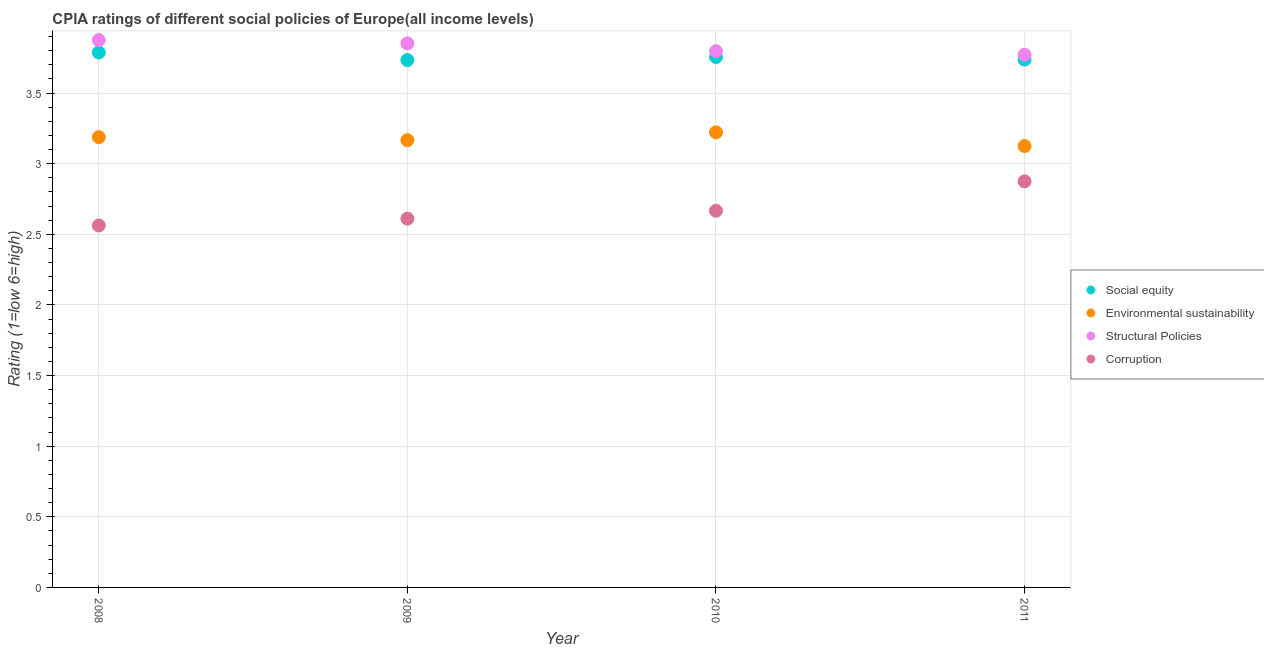How many different coloured dotlines are there?
Keep it short and to the point. 4. Is the number of dotlines equal to the number of legend labels?
Keep it short and to the point. Yes. What is the cpia rating of structural policies in 2010?
Provide a short and direct response. 3.8. Across all years, what is the maximum cpia rating of structural policies?
Offer a terse response. 3.88. Across all years, what is the minimum cpia rating of social equity?
Offer a very short reply. 3.73. What is the total cpia rating of structural policies in the graph?
Provide a short and direct response. 15.29. What is the difference between the cpia rating of structural policies in 2010 and that in 2011?
Your answer should be compact. 0.03. What is the difference between the cpia rating of corruption in 2011 and the cpia rating of social equity in 2008?
Provide a short and direct response. -0.91. What is the average cpia rating of social equity per year?
Provide a short and direct response. 3.75. In the year 2009, what is the difference between the cpia rating of social equity and cpia rating of environmental sustainability?
Your response must be concise. 0.57. In how many years, is the cpia rating of corruption greater than 2.4?
Offer a terse response. 4. What is the ratio of the cpia rating of environmental sustainability in 2009 to that in 2010?
Provide a short and direct response. 0.98. Is the cpia rating of environmental sustainability in 2008 less than that in 2010?
Your response must be concise. Yes. What is the difference between the highest and the second highest cpia rating of environmental sustainability?
Ensure brevity in your answer.  0.03. What is the difference between the highest and the lowest cpia rating of social equity?
Offer a terse response. 0.05. Is it the case that in every year, the sum of the cpia rating of environmental sustainability and cpia rating of structural policies is greater than the sum of cpia rating of social equity and cpia rating of corruption?
Your response must be concise. No. Is the cpia rating of environmental sustainability strictly greater than the cpia rating of corruption over the years?
Your answer should be compact. Yes. How many years are there in the graph?
Give a very brief answer. 4. What is the difference between two consecutive major ticks on the Y-axis?
Your answer should be very brief. 0.5. Are the values on the major ticks of Y-axis written in scientific E-notation?
Provide a short and direct response. No. Does the graph contain any zero values?
Ensure brevity in your answer.  No. How many legend labels are there?
Your answer should be very brief. 4. How are the legend labels stacked?
Give a very brief answer. Vertical. What is the title of the graph?
Your answer should be very brief. CPIA ratings of different social policies of Europe(all income levels). What is the label or title of the X-axis?
Make the answer very short. Year. What is the Rating (1=low 6=high) in Social equity in 2008?
Offer a terse response. 3.79. What is the Rating (1=low 6=high) in Environmental sustainability in 2008?
Your answer should be compact. 3.19. What is the Rating (1=low 6=high) of Structural Policies in 2008?
Keep it short and to the point. 3.88. What is the Rating (1=low 6=high) of Corruption in 2008?
Offer a very short reply. 2.56. What is the Rating (1=low 6=high) in Social equity in 2009?
Ensure brevity in your answer.  3.73. What is the Rating (1=low 6=high) in Environmental sustainability in 2009?
Your answer should be compact. 3.17. What is the Rating (1=low 6=high) of Structural Policies in 2009?
Offer a terse response. 3.85. What is the Rating (1=low 6=high) of Corruption in 2009?
Your response must be concise. 2.61. What is the Rating (1=low 6=high) in Social equity in 2010?
Keep it short and to the point. 3.76. What is the Rating (1=low 6=high) of Environmental sustainability in 2010?
Give a very brief answer. 3.22. What is the Rating (1=low 6=high) of Structural Policies in 2010?
Provide a short and direct response. 3.8. What is the Rating (1=low 6=high) in Corruption in 2010?
Give a very brief answer. 2.67. What is the Rating (1=low 6=high) of Social equity in 2011?
Ensure brevity in your answer.  3.74. What is the Rating (1=low 6=high) in Environmental sustainability in 2011?
Your answer should be compact. 3.12. What is the Rating (1=low 6=high) in Structural Policies in 2011?
Your answer should be compact. 3.77. What is the Rating (1=low 6=high) in Corruption in 2011?
Give a very brief answer. 2.88. Across all years, what is the maximum Rating (1=low 6=high) in Social equity?
Your response must be concise. 3.79. Across all years, what is the maximum Rating (1=low 6=high) in Environmental sustainability?
Offer a terse response. 3.22. Across all years, what is the maximum Rating (1=low 6=high) in Structural Policies?
Provide a succinct answer. 3.88. Across all years, what is the maximum Rating (1=low 6=high) of Corruption?
Your answer should be compact. 2.88. Across all years, what is the minimum Rating (1=low 6=high) in Social equity?
Offer a terse response. 3.73. Across all years, what is the minimum Rating (1=low 6=high) of Environmental sustainability?
Make the answer very short. 3.12. Across all years, what is the minimum Rating (1=low 6=high) in Structural Policies?
Your answer should be very brief. 3.77. Across all years, what is the minimum Rating (1=low 6=high) in Corruption?
Ensure brevity in your answer.  2.56. What is the total Rating (1=low 6=high) of Social equity in the graph?
Ensure brevity in your answer.  15.01. What is the total Rating (1=low 6=high) in Environmental sustainability in the graph?
Keep it short and to the point. 12.7. What is the total Rating (1=low 6=high) of Structural Policies in the graph?
Offer a very short reply. 15.29. What is the total Rating (1=low 6=high) of Corruption in the graph?
Your answer should be very brief. 10.72. What is the difference between the Rating (1=low 6=high) of Social equity in 2008 and that in 2009?
Your answer should be compact. 0.05. What is the difference between the Rating (1=low 6=high) of Environmental sustainability in 2008 and that in 2009?
Give a very brief answer. 0.02. What is the difference between the Rating (1=low 6=high) of Structural Policies in 2008 and that in 2009?
Ensure brevity in your answer.  0.02. What is the difference between the Rating (1=low 6=high) of Corruption in 2008 and that in 2009?
Your response must be concise. -0.05. What is the difference between the Rating (1=low 6=high) of Social equity in 2008 and that in 2010?
Your answer should be very brief. 0.03. What is the difference between the Rating (1=low 6=high) of Environmental sustainability in 2008 and that in 2010?
Provide a short and direct response. -0.03. What is the difference between the Rating (1=low 6=high) of Structural Policies in 2008 and that in 2010?
Keep it short and to the point. 0.08. What is the difference between the Rating (1=low 6=high) of Corruption in 2008 and that in 2010?
Keep it short and to the point. -0.1. What is the difference between the Rating (1=low 6=high) of Environmental sustainability in 2008 and that in 2011?
Ensure brevity in your answer.  0.06. What is the difference between the Rating (1=low 6=high) of Structural Policies in 2008 and that in 2011?
Provide a short and direct response. 0.1. What is the difference between the Rating (1=low 6=high) of Corruption in 2008 and that in 2011?
Give a very brief answer. -0.31. What is the difference between the Rating (1=low 6=high) of Social equity in 2009 and that in 2010?
Offer a very short reply. -0.02. What is the difference between the Rating (1=low 6=high) of Environmental sustainability in 2009 and that in 2010?
Your answer should be very brief. -0.06. What is the difference between the Rating (1=low 6=high) of Structural Policies in 2009 and that in 2010?
Your answer should be compact. 0.06. What is the difference between the Rating (1=low 6=high) in Corruption in 2009 and that in 2010?
Ensure brevity in your answer.  -0.06. What is the difference between the Rating (1=low 6=high) of Social equity in 2009 and that in 2011?
Provide a short and direct response. -0. What is the difference between the Rating (1=low 6=high) in Environmental sustainability in 2009 and that in 2011?
Offer a terse response. 0.04. What is the difference between the Rating (1=low 6=high) in Structural Policies in 2009 and that in 2011?
Make the answer very short. 0.08. What is the difference between the Rating (1=low 6=high) of Corruption in 2009 and that in 2011?
Ensure brevity in your answer.  -0.26. What is the difference between the Rating (1=low 6=high) in Social equity in 2010 and that in 2011?
Provide a short and direct response. 0.02. What is the difference between the Rating (1=low 6=high) in Environmental sustainability in 2010 and that in 2011?
Make the answer very short. 0.1. What is the difference between the Rating (1=low 6=high) of Structural Policies in 2010 and that in 2011?
Offer a very short reply. 0.03. What is the difference between the Rating (1=low 6=high) in Corruption in 2010 and that in 2011?
Give a very brief answer. -0.21. What is the difference between the Rating (1=low 6=high) of Social equity in 2008 and the Rating (1=low 6=high) of Environmental sustainability in 2009?
Make the answer very short. 0.62. What is the difference between the Rating (1=low 6=high) in Social equity in 2008 and the Rating (1=low 6=high) in Structural Policies in 2009?
Offer a terse response. -0.06. What is the difference between the Rating (1=low 6=high) in Social equity in 2008 and the Rating (1=low 6=high) in Corruption in 2009?
Offer a terse response. 1.18. What is the difference between the Rating (1=low 6=high) of Environmental sustainability in 2008 and the Rating (1=low 6=high) of Structural Policies in 2009?
Your answer should be compact. -0.66. What is the difference between the Rating (1=low 6=high) of Environmental sustainability in 2008 and the Rating (1=low 6=high) of Corruption in 2009?
Provide a short and direct response. 0.58. What is the difference between the Rating (1=low 6=high) in Structural Policies in 2008 and the Rating (1=low 6=high) in Corruption in 2009?
Keep it short and to the point. 1.26. What is the difference between the Rating (1=low 6=high) of Social equity in 2008 and the Rating (1=low 6=high) of Environmental sustainability in 2010?
Your answer should be very brief. 0.57. What is the difference between the Rating (1=low 6=high) of Social equity in 2008 and the Rating (1=low 6=high) of Structural Policies in 2010?
Your answer should be very brief. -0.01. What is the difference between the Rating (1=low 6=high) in Social equity in 2008 and the Rating (1=low 6=high) in Corruption in 2010?
Give a very brief answer. 1.12. What is the difference between the Rating (1=low 6=high) in Environmental sustainability in 2008 and the Rating (1=low 6=high) in Structural Policies in 2010?
Your response must be concise. -0.61. What is the difference between the Rating (1=low 6=high) in Environmental sustainability in 2008 and the Rating (1=low 6=high) in Corruption in 2010?
Your answer should be very brief. 0.52. What is the difference between the Rating (1=low 6=high) in Structural Policies in 2008 and the Rating (1=low 6=high) in Corruption in 2010?
Your answer should be compact. 1.21. What is the difference between the Rating (1=low 6=high) in Social equity in 2008 and the Rating (1=low 6=high) in Environmental sustainability in 2011?
Make the answer very short. 0.66. What is the difference between the Rating (1=low 6=high) of Social equity in 2008 and the Rating (1=low 6=high) of Structural Policies in 2011?
Your answer should be compact. 0.02. What is the difference between the Rating (1=low 6=high) in Social equity in 2008 and the Rating (1=low 6=high) in Corruption in 2011?
Your answer should be very brief. 0.91. What is the difference between the Rating (1=low 6=high) of Environmental sustainability in 2008 and the Rating (1=low 6=high) of Structural Policies in 2011?
Make the answer very short. -0.58. What is the difference between the Rating (1=low 6=high) of Environmental sustainability in 2008 and the Rating (1=low 6=high) of Corruption in 2011?
Your response must be concise. 0.31. What is the difference between the Rating (1=low 6=high) in Structural Policies in 2008 and the Rating (1=low 6=high) in Corruption in 2011?
Offer a very short reply. 1. What is the difference between the Rating (1=low 6=high) in Social equity in 2009 and the Rating (1=low 6=high) in Environmental sustainability in 2010?
Your answer should be compact. 0.51. What is the difference between the Rating (1=low 6=high) in Social equity in 2009 and the Rating (1=low 6=high) in Structural Policies in 2010?
Provide a succinct answer. -0.06. What is the difference between the Rating (1=low 6=high) in Social equity in 2009 and the Rating (1=low 6=high) in Corruption in 2010?
Your answer should be compact. 1.07. What is the difference between the Rating (1=low 6=high) of Environmental sustainability in 2009 and the Rating (1=low 6=high) of Structural Policies in 2010?
Give a very brief answer. -0.63. What is the difference between the Rating (1=low 6=high) of Structural Policies in 2009 and the Rating (1=low 6=high) of Corruption in 2010?
Keep it short and to the point. 1.19. What is the difference between the Rating (1=low 6=high) of Social equity in 2009 and the Rating (1=low 6=high) of Environmental sustainability in 2011?
Your response must be concise. 0.61. What is the difference between the Rating (1=low 6=high) in Social equity in 2009 and the Rating (1=low 6=high) in Structural Policies in 2011?
Give a very brief answer. -0.04. What is the difference between the Rating (1=low 6=high) in Social equity in 2009 and the Rating (1=low 6=high) in Corruption in 2011?
Provide a succinct answer. 0.86. What is the difference between the Rating (1=low 6=high) in Environmental sustainability in 2009 and the Rating (1=low 6=high) in Structural Policies in 2011?
Provide a short and direct response. -0.6. What is the difference between the Rating (1=low 6=high) in Environmental sustainability in 2009 and the Rating (1=low 6=high) in Corruption in 2011?
Offer a terse response. 0.29. What is the difference between the Rating (1=low 6=high) in Structural Policies in 2009 and the Rating (1=low 6=high) in Corruption in 2011?
Offer a very short reply. 0.98. What is the difference between the Rating (1=low 6=high) of Social equity in 2010 and the Rating (1=low 6=high) of Environmental sustainability in 2011?
Your answer should be compact. 0.63. What is the difference between the Rating (1=low 6=high) in Social equity in 2010 and the Rating (1=low 6=high) in Structural Policies in 2011?
Ensure brevity in your answer.  -0.02. What is the difference between the Rating (1=low 6=high) of Social equity in 2010 and the Rating (1=low 6=high) of Corruption in 2011?
Give a very brief answer. 0.88. What is the difference between the Rating (1=low 6=high) of Environmental sustainability in 2010 and the Rating (1=low 6=high) of Structural Policies in 2011?
Make the answer very short. -0.55. What is the difference between the Rating (1=low 6=high) of Environmental sustainability in 2010 and the Rating (1=low 6=high) of Corruption in 2011?
Offer a very short reply. 0.35. What is the difference between the Rating (1=low 6=high) in Structural Policies in 2010 and the Rating (1=low 6=high) in Corruption in 2011?
Offer a very short reply. 0.92. What is the average Rating (1=low 6=high) of Social equity per year?
Keep it short and to the point. 3.75. What is the average Rating (1=low 6=high) of Environmental sustainability per year?
Ensure brevity in your answer.  3.18. What is the average Rating (1=low 6=high) in Structural Policies per year?
Offer a terse response. 3.82. What is the average Rating (1=low 6=high) in Corruption per year?
Keep it short and to the point. 2.68. In the year 2008, what is the difference between the Rating (1=low 6=high) of Social equity and Rating (1=low 6=high) of Environmental sustainability?
Provide a short and direct response. 0.6. In the year 2008, what is the difference between the Rating (1=low 6=high) of Social equity and Rating (1=low 6=high) of Structural Policies?
Ensure brevity in your answer.  -0.09. In the year 2008, what is the difference between the Rating (1=low 6=high) of Social equity and Rating (1=low 6=high) of Corruption?
Your answer should be compact. 1.23. In the year 2008, what is the difference between the Rating (1=low 6=high) of Environmental sustainability and Rating (1=low 6=high) of Structural Policies?
Keep it short and to the point. -0.69. In the year 2008, what is the difference between the Rating (1=low 6=high) in Structural Policies and Rating (1=low 6=high) in Corruption?
Offer a very short reply. 1.31. In the year 2009, what is the difference between the Rating (1=low 6=high) in Social equity and Rating (1=low 6=high) in Environmental sustainability?
Provide a short and direct response. 0.57. In the year 2009, what is the difference between the Rating (1=low 6=high) in Social equity and Rating (1=low 6=high) in Structural Policies?
Your response must be concise. -0.12. In the year 2009, what is the difference between the Rating (1=low 6=high) of Social equity and Rating (1=low 6=high) of Corruption?
Offer a terse response. 1.12. In the year 2009, what is the difference between the Rating (1=low 6=high) in Environmental sustainability and Rating (1=low 6=high) in Structural Policies?
Offer a terse response. -0.69. In the year 2009, what is the difference between the Rating (1=low 6=high) of Environmental sustainability and Rating (1=low 6=high) of Corruption?
Provide a short and direct response. 0.56. In the year 2009, what is the difference between the Rating (1=low 6=high) in Structural Policies and Rating (1=low 6=high) in Corruption?
Keep it short and to the point. 1.24. In the year 2010, what is the difference between the Rating (1=low 6=high) of Social equity and Rating (1=low 6=high) of Environmental sustainability?
Provide a short and direct response. 0.53. In the year 2010, what is the difference between the Rating (1=low 6=high) in Social equity and Rating (1=low 6=high) in Structural Policies?
Make the answer very short. -0.04. In the year 2010, what is the difference between the Rating (1=low 6=high) of Social equity and Rating (1=low 6=high) of Corruption?
Ensure brevity in your answer.  1.09. In the year 2010, what is the difference between the Rating (1=low 6=high) of Environmental sustainability and Rating (1=low 6=high) of Structural Policies?
Provide a short and direct response. -0.57. In the year 2010, what is the difference between the Rating (1=low 6=high) of Environmental sustainability and Rating (1=low 6=high) of Corruption?
Make the answer very short. 0.56. In the year 2010, what is the difference between the Rating (1=low 6=high) of Structural Policies and Rating (1=low 6=high) of Corruption?
Offer a terse response. 1.13. In the year 2011, what is the difference between the Rating (1=low 6=high) of Social equity and Rating (1=low 6=high) of Environmental sustainability?
Make the answer very short. 0.61. In the year 2011, what is the difference between the Rating (1=low 6=high) in Social equity and Rating (1=low 6=high) in Structural Policies?
Offer a very short reply. -0.03. In the year 2011, what is the difference between the Rating (1=low 6=high) of Social equity and Rating (1=low 6=high) of Corruption?
Make the answer very short. 0.86. In the year 2011, what is the difference between the Rating (1=low 6=high) of Environmental sustainability and Rating (1=low 6=high) of Structural Policies?
Ensure brevity in your answer.  -0.65. In the year 2011, what is the difference between the Rating (1=low 6=high) in Environmental sustainability and Rating (1=low 6=high) in Corruption?
Your response must be concise. 0.25. In the year 2011, what is the difference between the Rating (1=low 6=high) of Structural Policies and Rating (1=low 6=high) of Corruption?
Ensure brevity in your answer.  0.9. What is the ratio of the Rating (1=low 6=high) of Social equity in 2008 to that in 2009?
Your answer should be very brief. 1.01. What is the ratio of the Rating (1=low 6=high) in Environmental sustainability in 2008 to that in 2009?
Give a very brief answer. 1.01. What is the ratio of the Rating (1=low 6=high) in Corruption in 2008 to that in 2009?
Make the answer very short. 0.98. What is the ratio of the Rating (1=low 6=high) in Social equity in 2008 to that in 2010?
Your answer should be very brief. 1.01. What is the ratio of the Rating (1=low 6=high) in Structural Policies in 2008 to that in 2010?
Give a very brief answer. 1.02. What is the ratio of the Rating (1=low 6=high) in Corruption in 2008 to that in 2010?
Provide a succinct answer. 0.96. What is the ratio of the Rating (1=low 6=high) of Social equity in 2008 to that in 2011?
Your response must be concise. 1.01. What is the ratio of the Rating (1=low 6=high) in Structural Policies in 2008 to that in 2011?
Make the answer very short. 1.03. What is the ratio of the Rating (1=low 6=high) in Corruption in 2008 to that in 2011?
Offer a very short reply. 0.89. What is the ratio of the Rating (1=low 6=high) of Social equity in 2009 to that in 2010?
Keep it short and to the point. 0.99. What is the ratio of the Rating (1=low 6=high) of Environmental sustainability in 2009 to that in 2010?
Make the answer very short. 0.98. What is the ratio of the Rating (1=low 6=high) in Structural Policies in 2009 to that in 2010?
Make the answer very short. 1.01. What is the ratio of the Rating (1=low 6=high) of Corruption in 2009 to that in 2010?
Your response must be concise. 0.98. What is the ratio of the Rating (1=low 6=high) of Social equity in 2009 to that in 2011?
Give a very brief answer. 1. What is the ratio of the Rating (1=low 6=high) of Environmental sustainability in 2009 to that in 2011?
Offer a terse response. 1.01. What is the ratio of the Rating (1=low 6=high) in Structural Policies in 2009 to that in 2011?
Provide a succinct answer. 1.02. What is the ratio of the Rating (1=low 6=high) of Corruption in 2009 to that in 2011?
Provide a succinct answer. 0.91. What is the ratio of the Rating (1=low 6=high) in Social equity in 2010 to that in 2011?
Give a very brief answer. 1. What is the ratio of the Rating (1=low 6=high) of Environmental sustainability in 2010 to that in 2011?
Your answer should be very brief. 1.03. What is the ratio of the Rating (1=low 6=high) of Structural Policies in 2010 to that in 2011?
Your answer should be very brief. 1.01. What is the ratio of the Rating (1=low 6=high) of Corruption in 2010 to that in 2011?
Provide a succinct answer. 0.93. What is the difference between the highest and the second highest Rating (1=low 6=high) of Social equity?
Your response must be concise. 0.03. What is the difference between the highest and the second highest Rating (1=low 6=high) of Environmental sustainability?
Ensure brevity in your answer.  0.03. What is the difference between the highest and the second highest Rating (1=low 6=high) of Structural Policies?
Offer a very short reply. 0.02. What is the difference between the highest and the second highest Rating (1=low 6=high) of Corruption?
Offer a terse response. 0.21. What is the difference between the highest and the lowest Rating (1=low 6=high) in Social equity?
Your answer should be very brief. 0.05. What is the difference between the highest and the lowest Rating (1=low 6=high) in Environmental sustainability?
Keep it short and to the point. 0.1. What is the difference between the highest and the lowest Rating (1=low 6=high) in Structural Policies?
Your answer should be very brief. 0.1. What is the difference between the highest and the lowest Rating (1=low 6=high) of Corruption?
Your answer should be very brief. 0.31. 